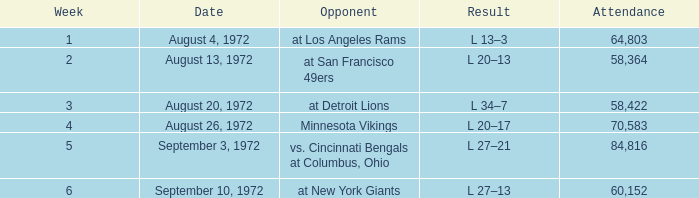What is the lowest attendance on September 3, 1972? 84816.0. 